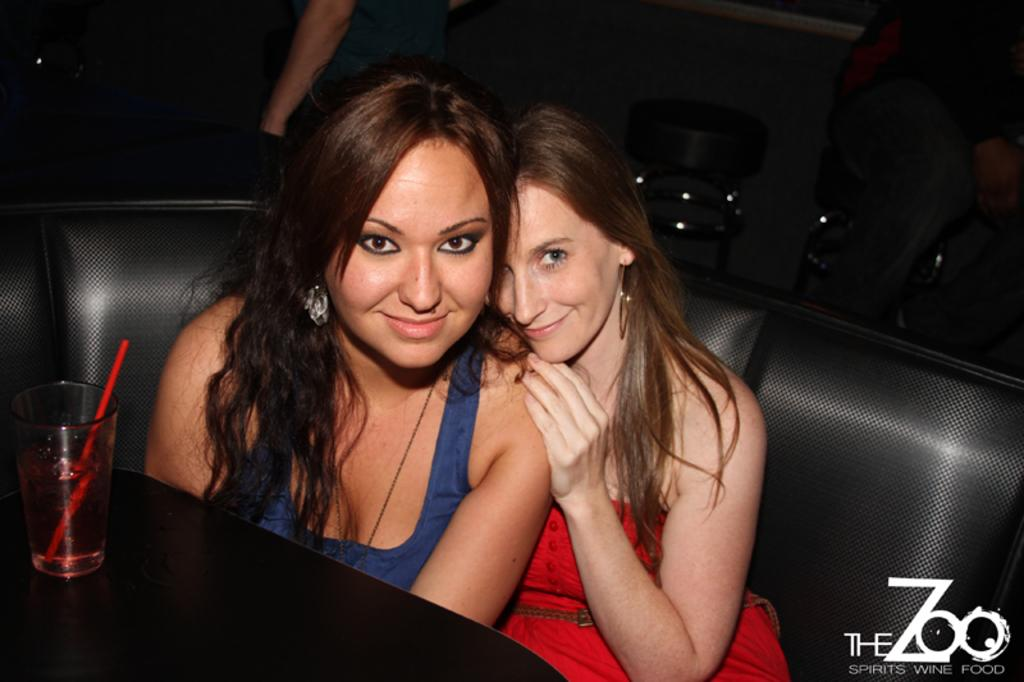How many persons are in the image? There are persons in the image. What are two of the persons doing in the image? Two of the persons are sitting on a couch. What is on the table in front of the couch? There is a glass of liquid on a table in front of the couch. What is inside the glass of liquid? There is a straw in the glass of liquid. What can be seen behind the couch in the image? There are chairs visible behind the couch. What type of hearing aid is the person wearing in the image? There is no person wearing a hearing aid in the image. What route are the persons taking in the image? There is no indication of a route or journey in the image; it shows a scene with persons sitting on a couch and other objects. 